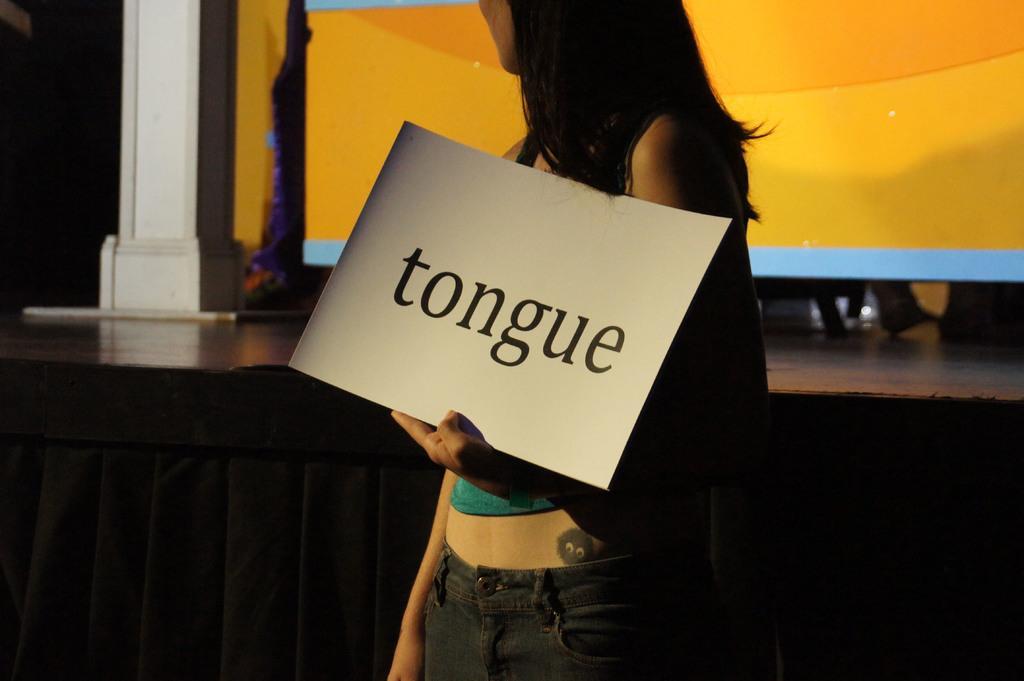How would you summarize this image in a sentence or two? In the middle of this image, there is a woman holding a white color poster with a hand and standing. In the background, there is a white color pillar, there is a screen arranged on a stage and there are other objects. 